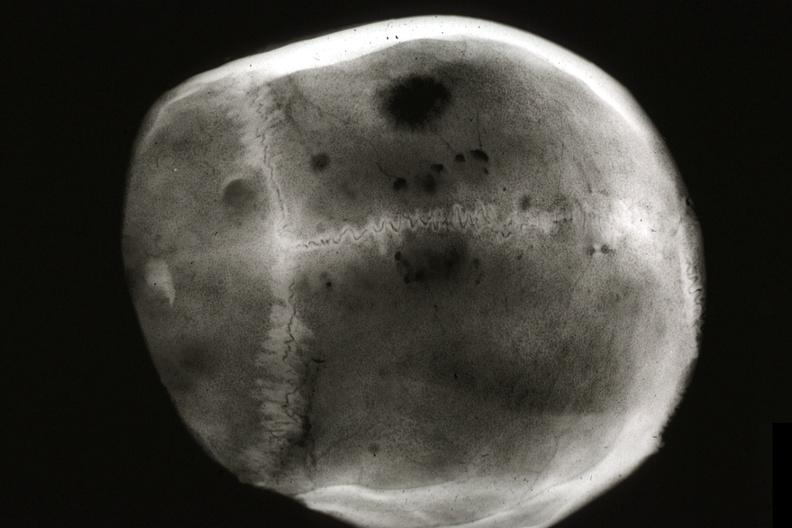does this great toe show x-ray skull cap multiple lytic lesions prostate adenocarcinoma?
Answer the question using a single word or phrase. No 